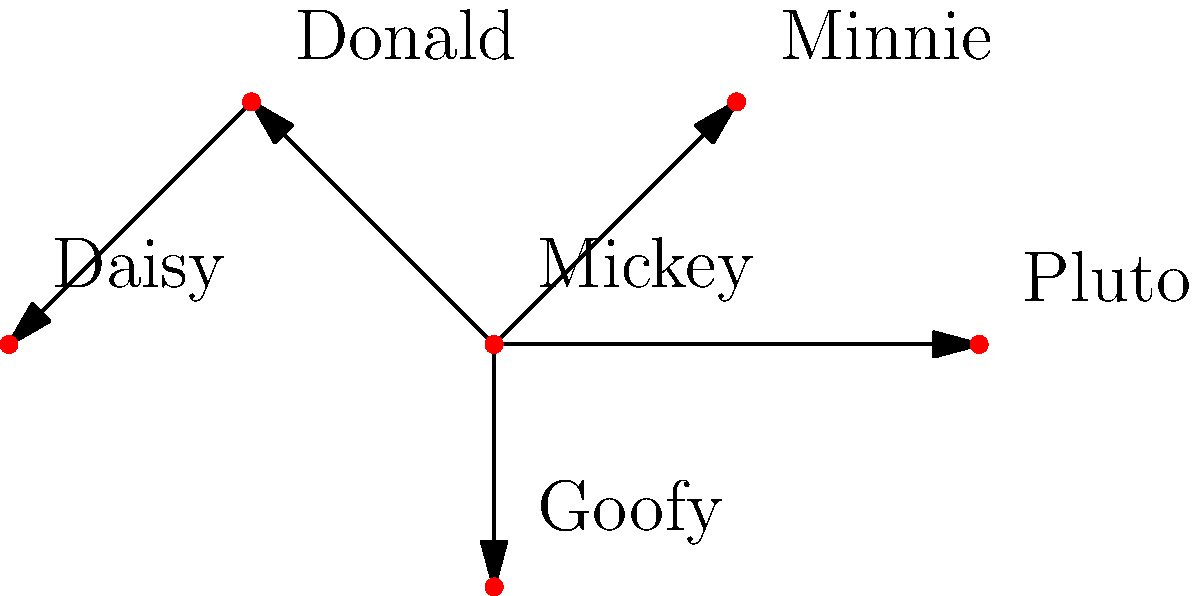In the network diagram representing relationships between classic cartoon characters, which character has the most direct connections, and how many connections does this character have? To answer this question, we need to analyze the network diagram and count the connections for each character:

1. Mickey: Connected to Minnie, Donald, Goofy, and Pluto (4 connections)
2. Minnie: Connected to Mickey (1 connection)
3. Donald: Connected to Mickey and Daisy (2 connections)
4. Goofy: Connected to Mickey (1 connection)
5. Pluto: Connected to Mickey (1 connection)
6. Daisy: Connected to Donald (1 connection)

By examining the diagram, we can see that Mickey has the most direct connections with four arrows pointing outward from his node. These connections link Mickey to Minnie, Donald, Goofy, and Pluto.

This network structure reflects Mickey's central role in the classic Disney cartoon universe, often serving as the main character and connecting various storylines and relationships.
Answer: Mickey, 4 connections 